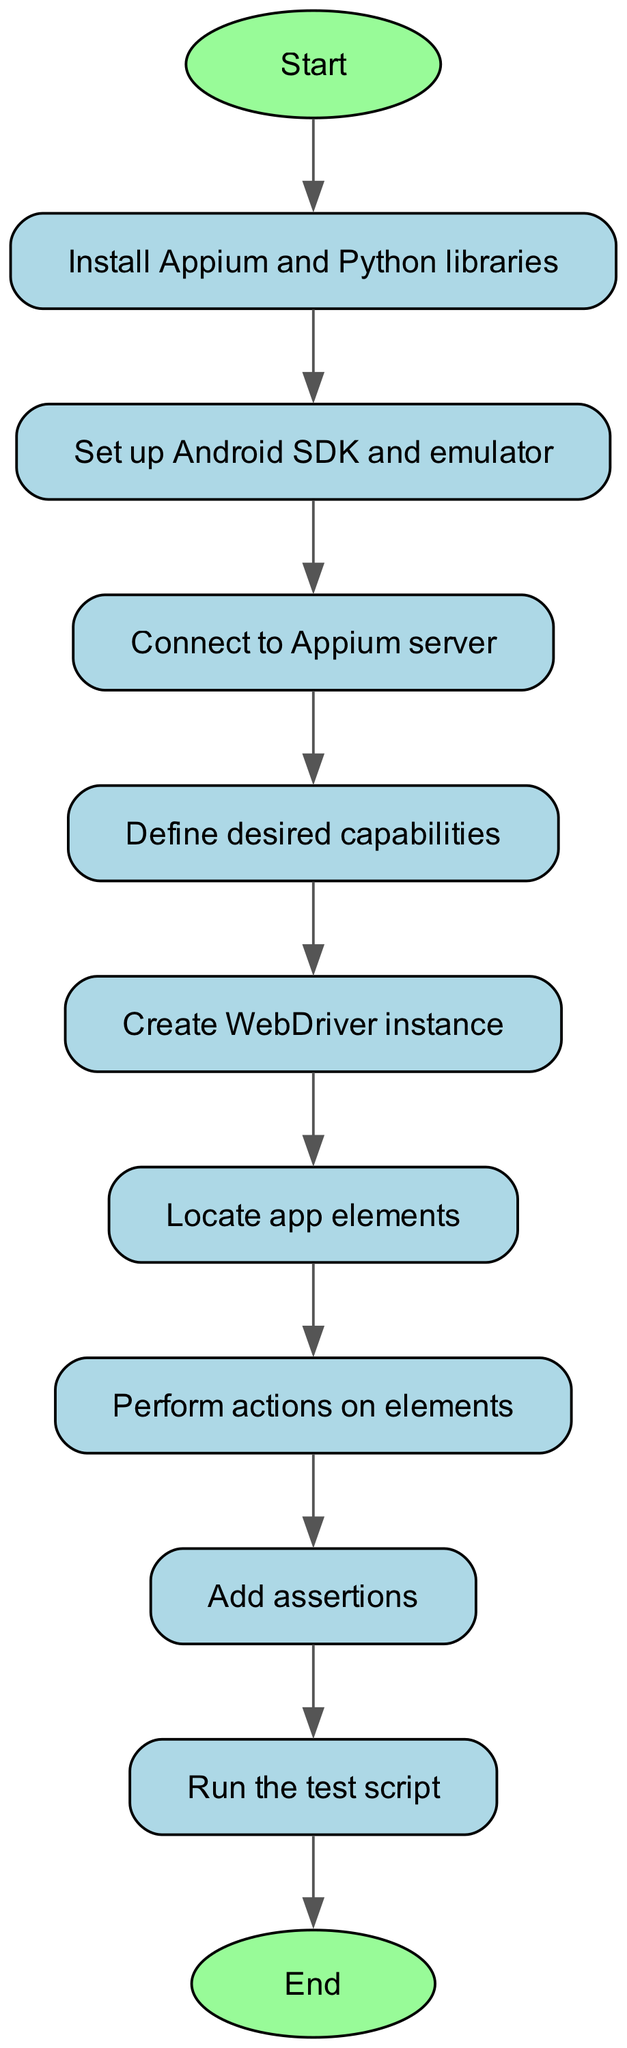What's the first step in the flowchart? The flowchart begins at the "Start" node, indicating the initiation of the process for creating a test script. Therefore, the first step is to start the process.
Answer: Start How many nodes are in the flowchart? To determine the total number of nodes, we can count each unique step in the diagram. There are ten distinct steps defined in the flowchart.
Answer: Ten What is the last step before ending the flowchart? The flowchart progresses from node "Run" directly to the "End" node. Thus, the last step before ending is to run the test script.
Answer: Run the test script Which node follows the "Connect to Appium server" node? The flowchart shows that the "Connect to Appium server" node leads directly to the "Define desired capabilities" node. Hence, the next step is to define desired capabilities.
Answer: Define desired capabilities How many edges connect the nodes? Each connection in the flowchart represents an edge, and we can count them. There are nine defined connections or edges in this specific diagram.
Answer: Nine What capability is defined after setting up the Android SDK and emulator? The flowchart indicates that after setting up the Android SDK and emulator, the next step is to connect to the Appium server. Therefore, the defined capability follows this connection.
Answer: Connect to Appium server Which node is not directly connected to the "End" node? An examination of the connections shows that the "Create WebDriver instance" node does not connect directly to the "End" node; it instead connects to the "Locate app elements" node.
Answer: Create WebDriver instance What step involves interaction with app elements? The flowchart specifically includes a step labeled "Perform actions on elements" that indicates interaction with app elements. This is the relevant step identified in the process.
Answer: Perform actions on elements 